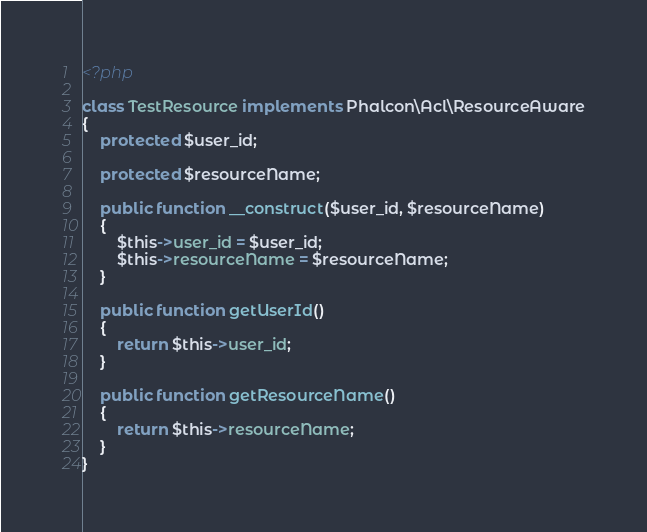Convert code to text. <code><loc_0><loc_0><loc_500><loc_500><_PHP_><?php

class TestResource implements Phalcon\Acl\ResourceAware
{
    protected $user_id;

    protected $resourceName;

    public function __construct($user_id, $resourceName)
    {
        $this->user_id = $user_id;
        $this->resourceName = $resourceName;
    }

    public function getUserId()
    {
        return $this->user_id;
    }

    public function getResourceName()
    {
        return $this->resourceName;
    }
}
</code> 